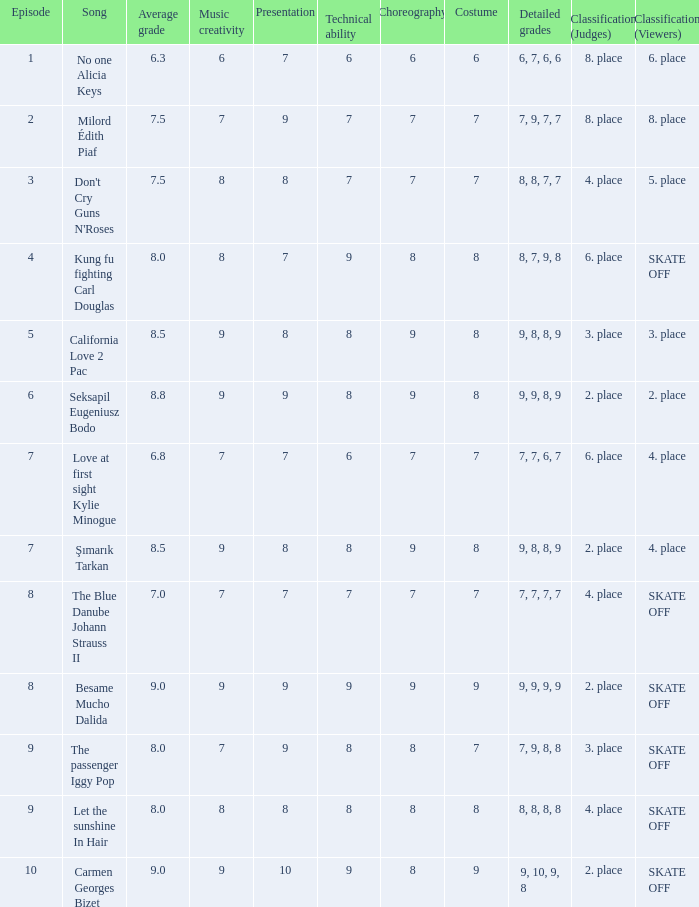Name the average grade for şımarık tarkan 8.5. 